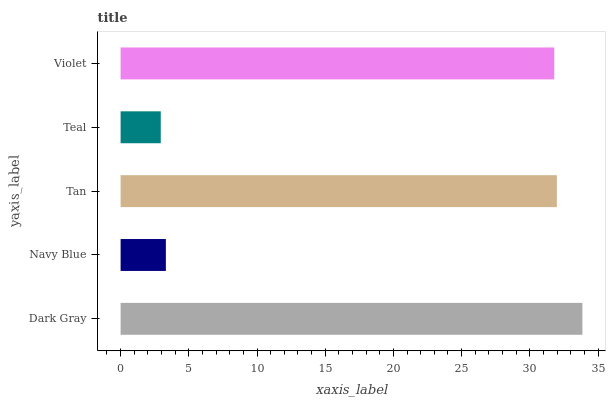Is Teal the minimum?
Answer yes or no. Yes. Is Dark Gray the maximum?
Answer yes or no. Yes. Is Navy Blue the minimum?
Answer yes or no. No. Is Navy Blue the maximum?
Answer yes or no. No. Is Dark Gray greater than Navy Blue?
Answer yes or no. Yes. Is Navy Blue less than Dark Gray?
Answer yes or no. Yes. Is Navy Blue greater than Dark Gray?
Answer yes or no. No. Is Dark Gray less than Navy Blue?
Answer yes or no. No. Is Violet the high median?
Answer yes or no. Yes. Is Violet the low median?
Answer yes or no. Yes. Is Tan the high median?
Answer yes or no. No. Is Dark Gray the low median?
Answer yes or no. No. 